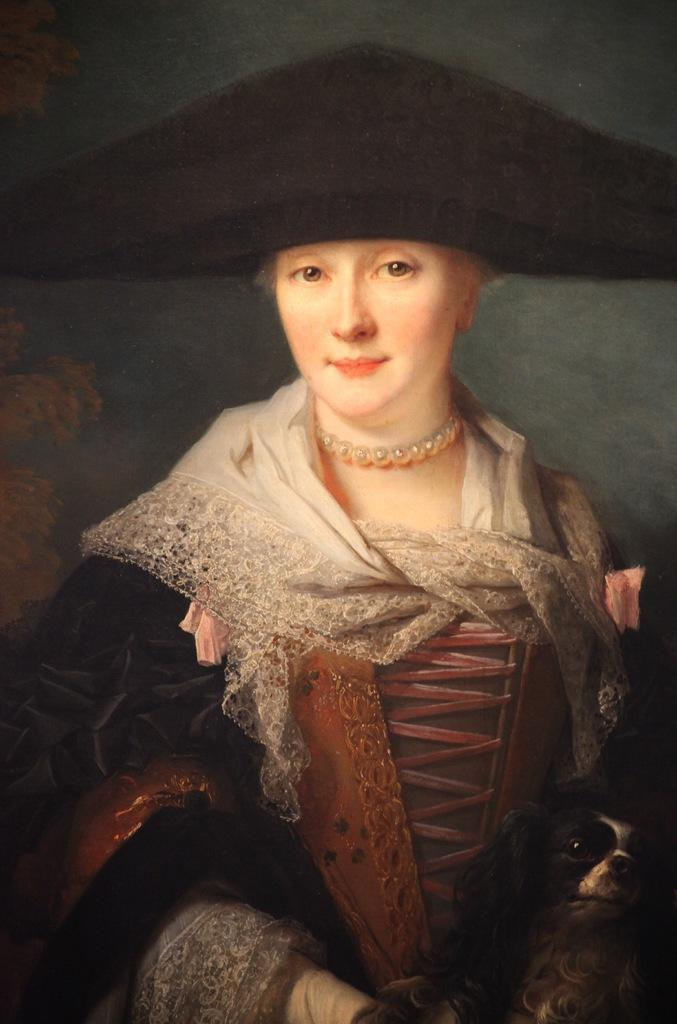What is present in the image? There is a person in the image. Can you describe the person's attire? The person is wearing clothes and a hat. What noise is the person's grandmother making in the image? There is no mention of a grandmother or any noise in the image. 